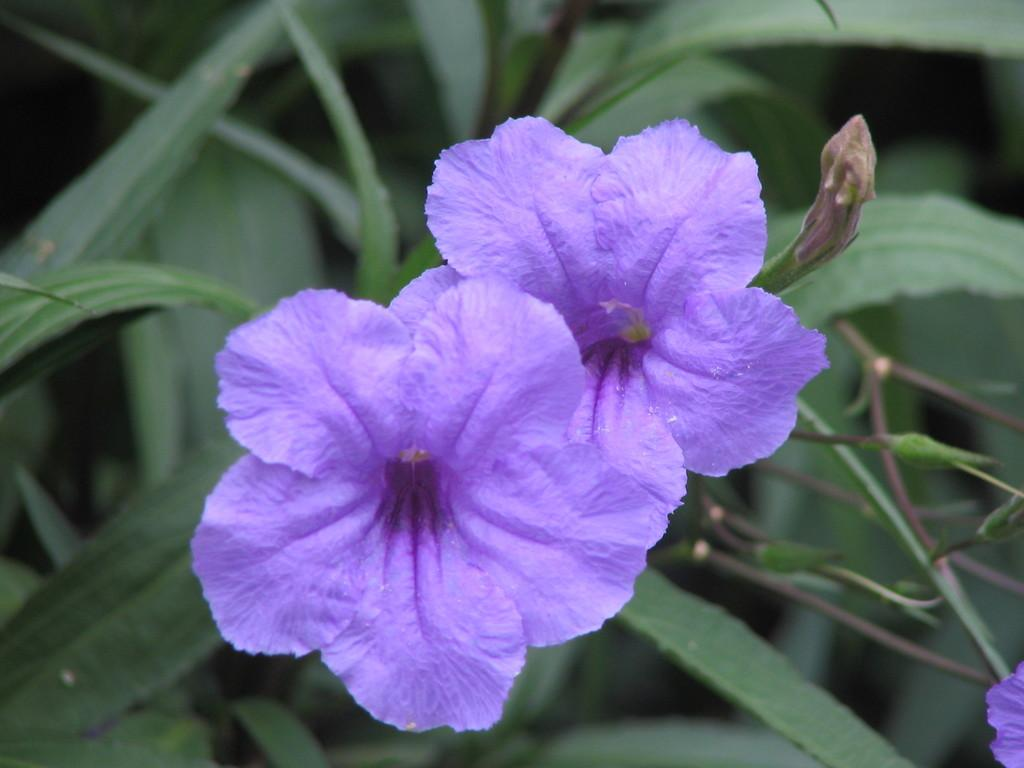What type of living organism is present in the image? There is a plant in the image. What specific features can be observed on the plant? The plant has flowers, buds, and leaves. What type of cake is displayed in the frame in the image? There is no cake or frame present in the image; it features a plant with flowers, buds, and leaves. 